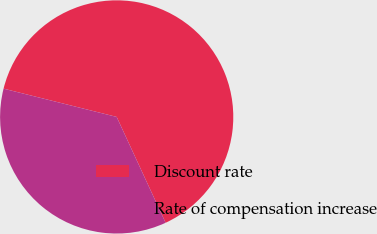Convert chart to OTSL. <chart><loc_0><loc_0><loc_500><loc_500><pie_chart><fcel>Discount rate<fcel>Rate of compensation increase<nl><fcel>64.21%<fcel>35.79%<nl></chart> 